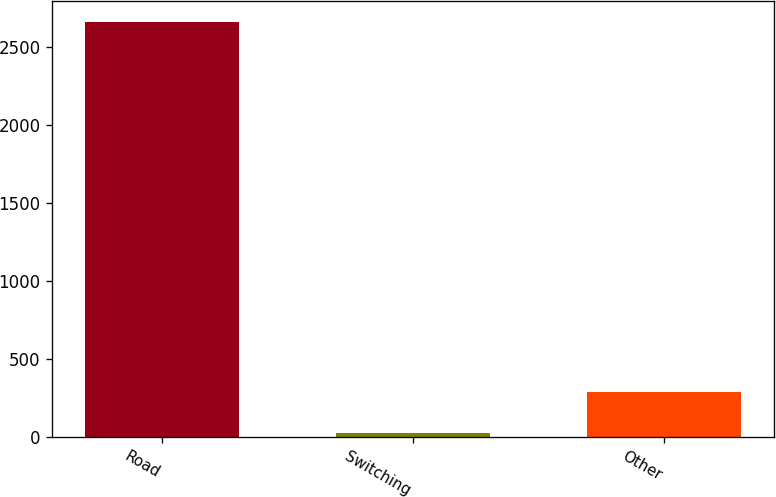Convert chart to OTSL. <chart><loc_0><loc_0><loc_500><loc_500><bar_chart><fcel>Road<fcel>Switching<fcel>Other<nl><fcel>2659<fcel>26<fcel>289.3<nl></chart> 